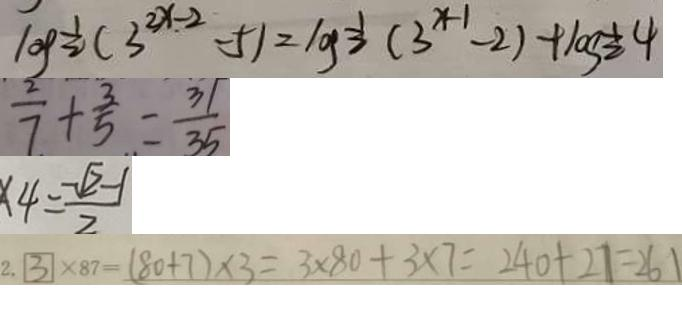Convert formula to latex. <formula><loc_0><loc_0><loc_500><loc_500>\log \frac { 1 } { 2 } ( 3 ^ { 2 x - 2 } - 5 ) = \log \frac { 1 } { 2 } ( 3 ^ { x - 1 } - 2 ) + \log \frac { 1 } { 2 } 4 
 \frac { 2 } { 7 } + \frac { 3 } { 5 } = \frac { 3 1 } { 3 5 } 
 x 4 = \frac { - \sqrt { 2 } - 1 } { 2 } 
 2 . 3 \times 8 7 = ( 8 0 + 7 ) \times 3 = 3 \times 8 0 + 3 \times 7 = 2 4 0 + 2 7 = 2 6 1</formula> 